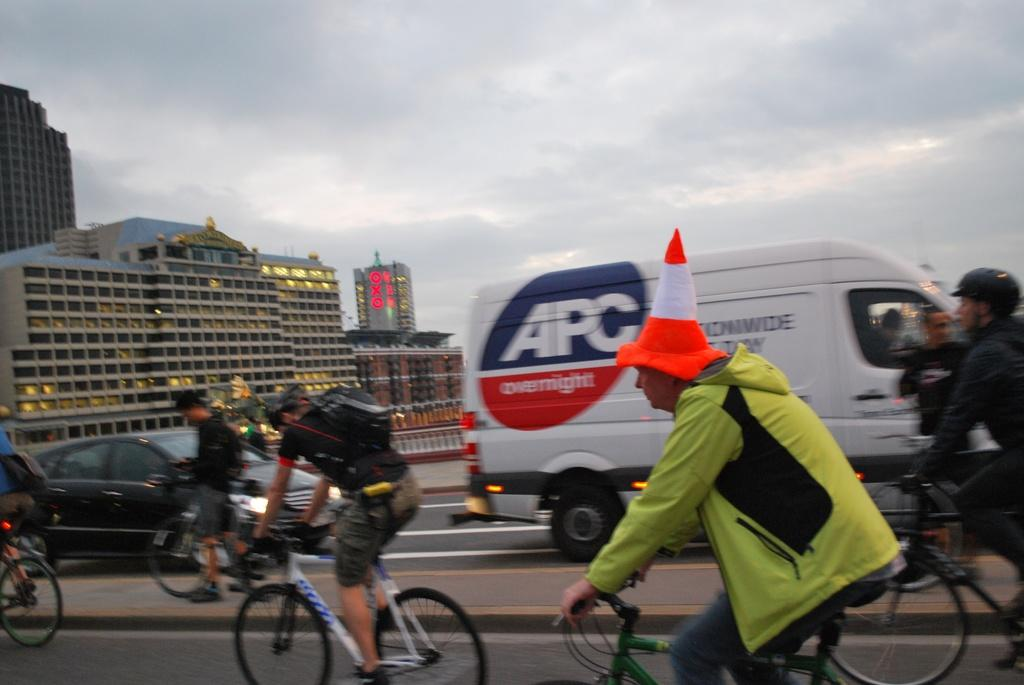What are the people in the image doing? The people in the image are riding bicycles on the road. What other vehicles are present on the road? There is a van moving on the road, and a car is following the van. What can be seen in the background of the image? There are many buildings in the background. What type of sail can be seen on the bicycles in the image? There are no sails present on the bicycles in the image; they are being ridden on a road. 